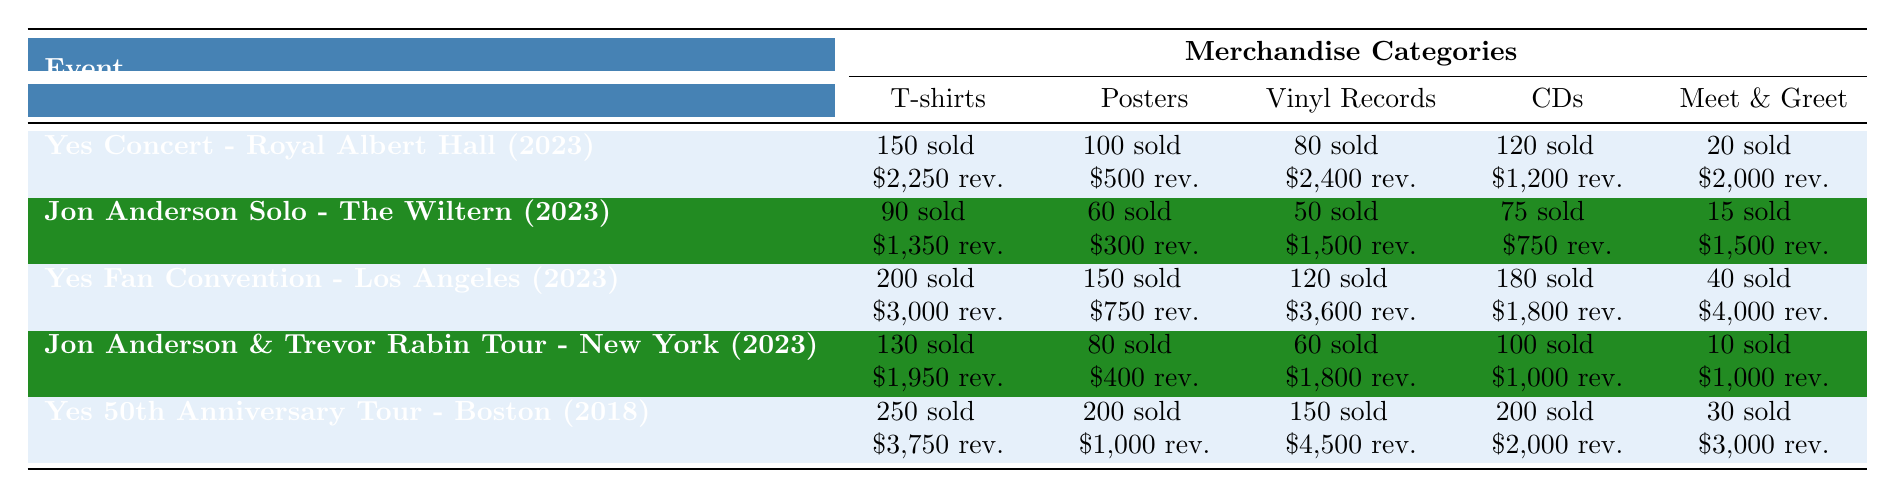What was the total revenue from CD sales at the Yes Concert - Royal Albert Hall in 2023? According to the table, the revenue from CD sales at the Yes Concert - Royal Albert Hall is \$1,200.
Answer: \$1,200 Which event had the highest quantity of vinyl records sold? The Yes Fan Convention - Los Angeles had the highest quantity of vinyl records sold at 120.
Answer: Yes Fan Convention - Los Angeles How much more revenue was generated from T-shirt sales at the Yes Fan Convention - Los Angeles compared to the Jon Anderson Solo Performance? The Yes Fan Convention - Los Angeles generated \$3,000 from T-shirt sales, while Jon Anderson Solo Performance generated \$1,350. The difference is \$3,000 - \$1,350 = \$1,650.
Answer: \$1,650 Did the Yes 50th Anniversary Tour - Boston have more posters sold than the Jon Anderson & Trevor Rabin Tour - New York? Yes 50th Anniversary Tour - Boston sold 200 posters, whereas Jon Anderson & Trevor Rabin Tour - New York sold 80 posters. Thus, Yes 50th Anniversary Tour - Boston had more posters sold.
Answer: Yes Calculate the total revenue from meet and greet packages across all events. Sum the total revenues from meet and greet packages for each event: (20 + 15 + 40 + 10 + 30) = 115 sold. Then sum revenues: \$2,000 + \$1,500 + \$4,000 + \$1,000 + \$3,000 = \$11,500.
Answer: \$11,500 What percentage of the total sales revenue at the Yes Fan Convention - Los Angeles came from vinyl record sales? The total revenue from the Yes Fan Convention - Los Angeles is \$3,000 (T-shirts) + \$750 (posters) + \$3,600 (vinyl records) + \$1,800 (CDs) + \$4,000 (meet and greet) = \$13,150. Revenue from vinyl records is \$3,600. The percentage is (3,600 / 13,150) * 100 ≈ 27.4%.
Answer: 27.4% Which event had the least revenue from poster sales? Jon Anderson Solo Performance had the least revenue from poster sales, totaling \$300.
Answer: Jon Anderson Solo Performance What was the average quantity of T-shirts sold across all events? Add the quantity of T-shirts sold: 150 + 90 + 200 + 130 + 250 = 820. Divide by the number of events (5): 820 / 5 = 164.
Answer: 164 Was the total revenue from the meet and greet packages at the Yes 50th Anniversary Tour - Boston greater than \$2,500? The total revenue from meet and greet packages at the Yes 50th Anniversary Tour - Boston is \$3,000, which is greater than \$2,500.
Answer: Yes How many more total shirts were sold at the Yes 50th Anniversary Tour - Boston compared to the Yes Concert - Royal Albert Hall? Yes 50th Anniversary Tour - Boston sold 250 shirts, while Yes Concert - Royal Albert Hall sold 150 shirts. The difference is 250 - 150 = 100.
Answer: 100 